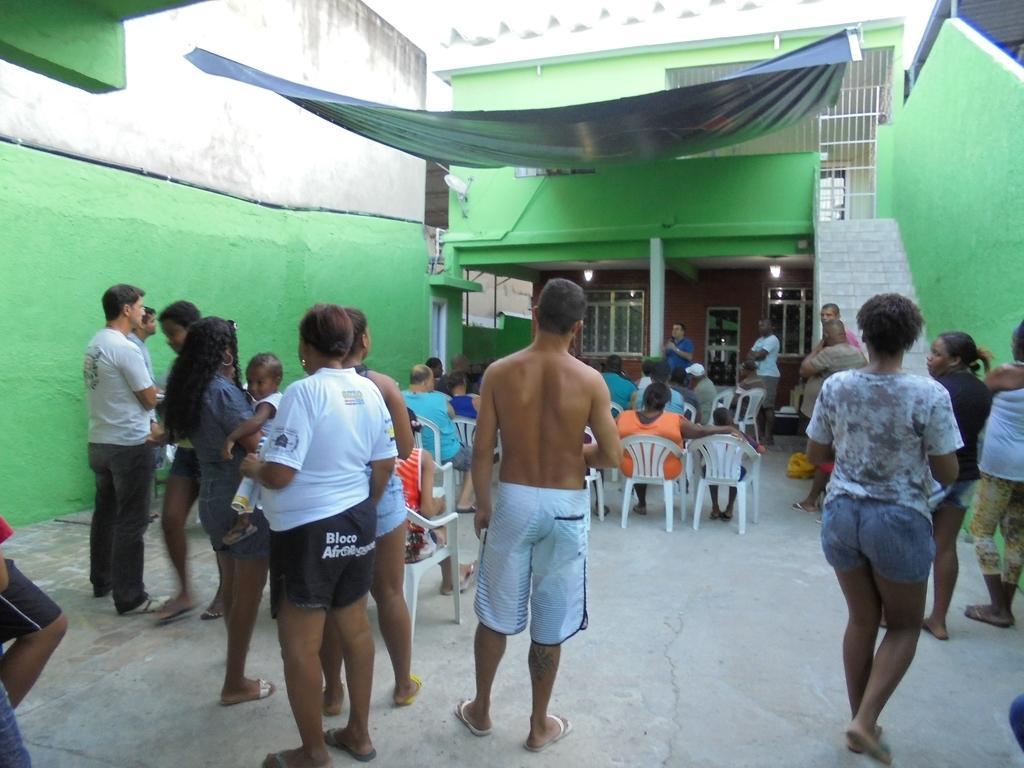Please provide a concise description of this image. Here we can see a group of people. Few people are sitting on chairs. Wall is in green color. Far there is a pillar, windows and lights. 